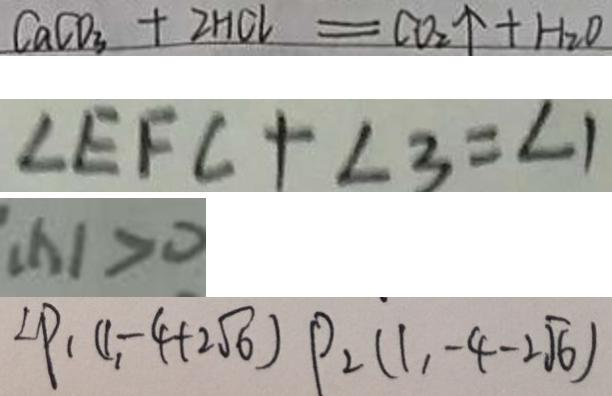Convert formula to latex. <formula><loc_0><loc_0><loc_500><loc_500>C a C O _ { 3 } + 2 H C l = C O _ { 2 } \uparrow + H _ { 2 } O 
 \angle E F C + \angle 3 = \angle 1 
 ( x ) > 0 
 \angle P _ { 1 } ( 1 , - 4 + 2 \sqrt { 6 } ) P _ { 2 } ( 1 , - 4 - 2 \sqrt { 6 } )</formula> 